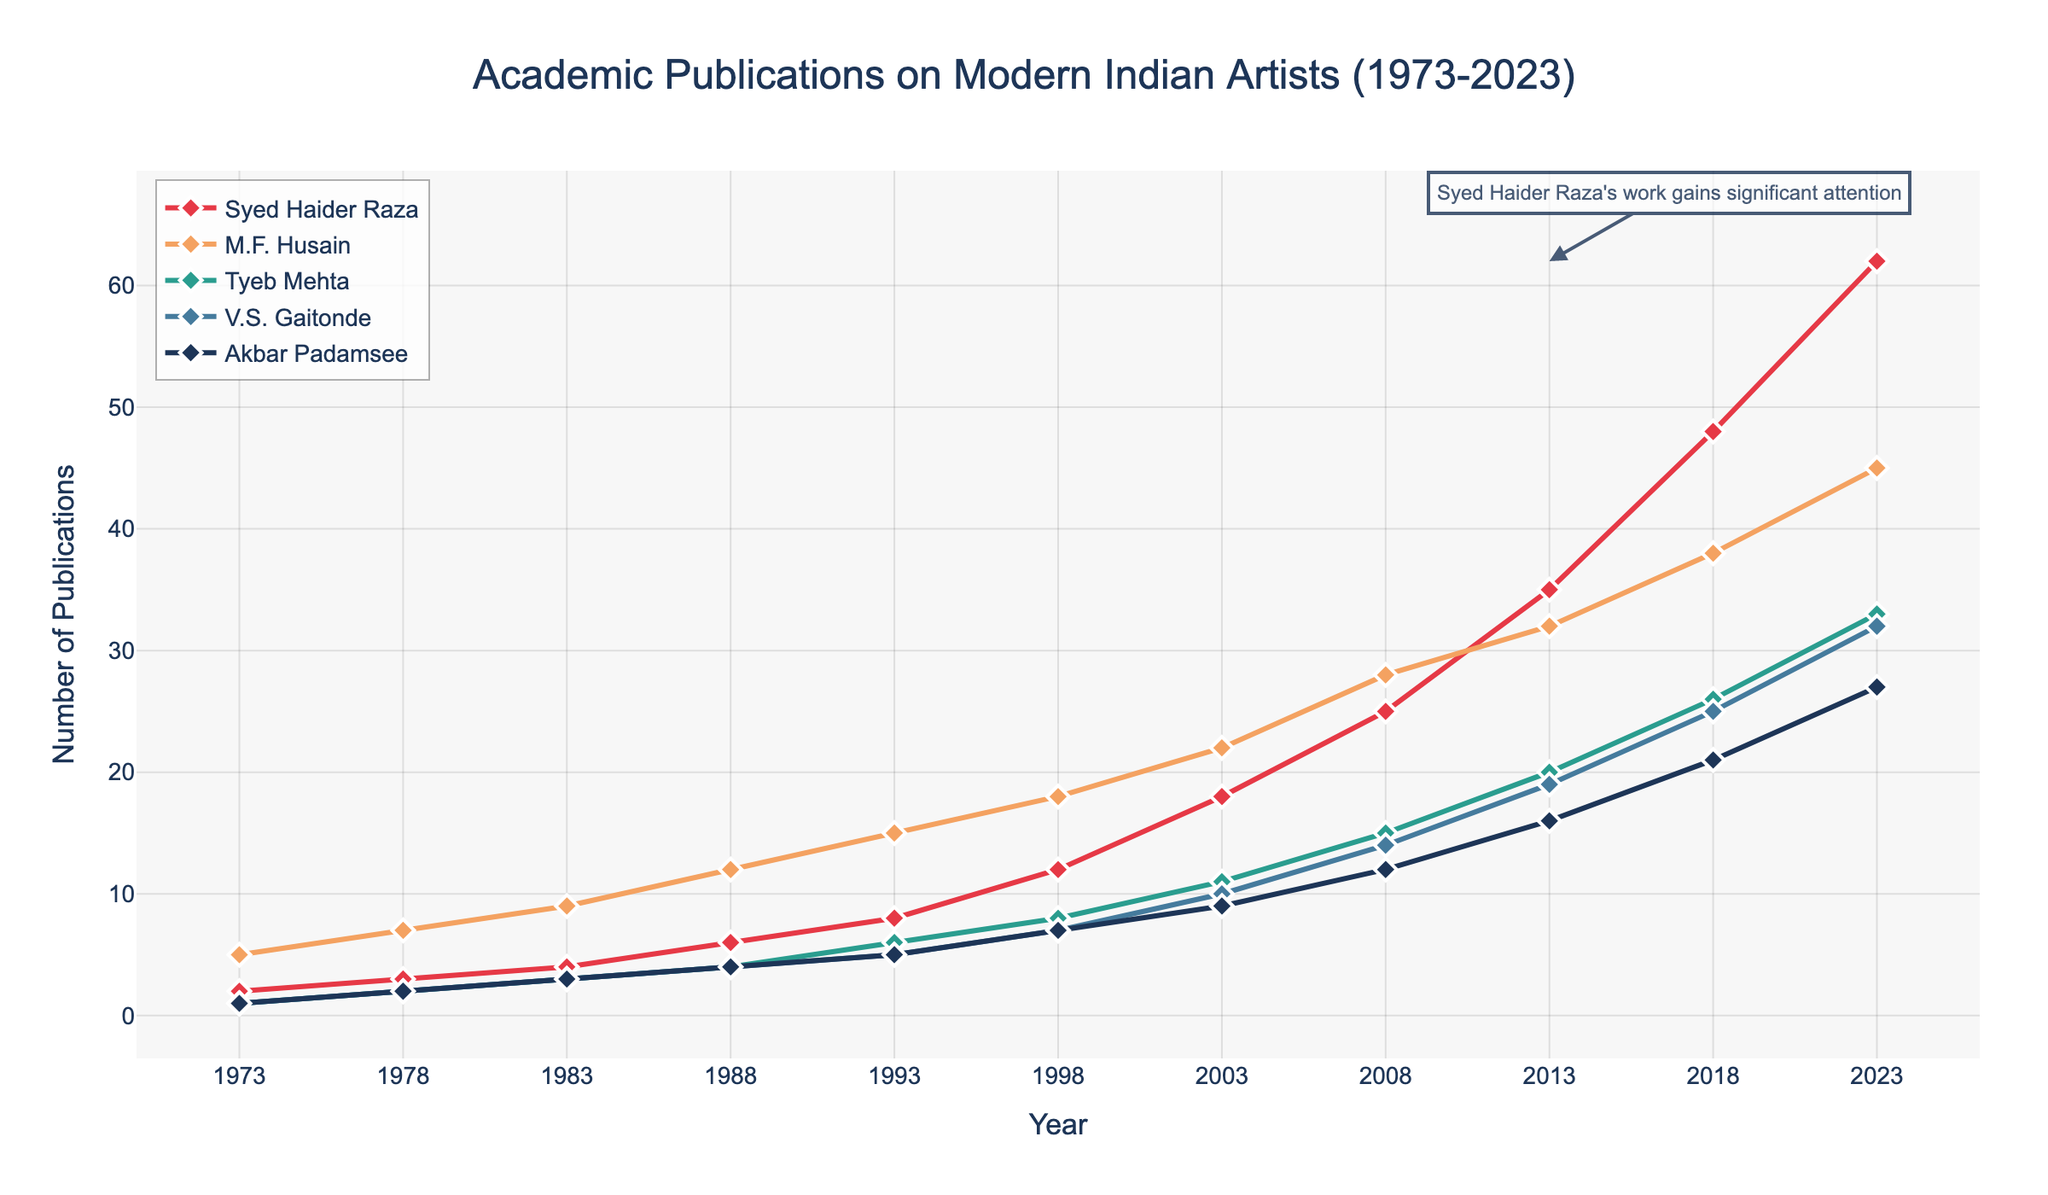What is the trend in the number of publications about Syed Haider Raza from 1973 to 2023? The number of publications about Syed Haider Raza consistently increases over the 50-year span, starting from 2 in 1973 and reaching 62 in 2023. This indicates growing academic interest in his work.
Answer: Increasing trend Which artist had the highest number of publications in 2023? In 2023, Syed Haider Raza had the highest number of publications at 62, compared to M.F. Husain (45), Tyeb Mehta (33), V.S. Gaitonde (32), and Akbar Padamsee (27).
Answer: Syed Haider Raza How did the number of publications about M.F. Husain and V.S. Gaitonde compare in 1993? In 1993, M.F. Husain had 15 publications while V.S. Gaitonde had 5 publications. M.F. Husain had 10 more publications than V.S. Gaitonde.
Answer: M.F. Husain had 10 more What is the combined number of publications about Tyeb Mehta and Akbar Padamsee in 1988? In 1988, Tyeb Mehta had 4 publications, and Akbar Padamsee had 4 publications as well. Combined, they had 4 + 4 = 8 publications.
Answer: 8 Which artist showed the greatest increase in the number of publications from 2013 to 2023? Syed Haider Raza's publications increased from 35 in 2013 to 62 in 2023. That's an increase of 62 - 35 = 27 publications, the largest among the artists.
Answer: Syed Haider Raza What's the average number of publications across all artists in 2003? In 2003, the artists had the following publications: Syed Haider Raza (18), M.F. Husain (22), Tyeb Mehta (11), V.S. Gaitonde (10), and Akbar Padamsee (9). The average is (18 + 22 + 11 + 10 + 9) / 5 = 14.
Answer: 14 Between 1973 and 2023, which artist saw the slowest growth in the number of publications? Akbar Padamsee had the slowest growth, increasing from 1 publication in 1973 to 27 publications in 2023. This constitutes an increase of 27 - 1 = 26 publications, the smallest growth among the listed artists.
Answer: Akbar Padamsee How many years did it take for Syed Haider Raza's publications to surpass those of M.F. Husain? Initially, in 1973, M.F. Husain had more publications (5) than Syed Haider Raza (2). Syed Haider Raza surpassed M.F. Husain in 2013 when Raza had 35 publications and Husain had 32, taking 40 years (2013 - 1973).
Answer: 40 years What's the difference in the number of publications about V.S. Gaitonde between 2013 and 2023? In 2013, V.S. Gaitonde had 19 publications. By 2023, this number increased to 32. The difference is 32 - 19 = 13.
Answer: 13 